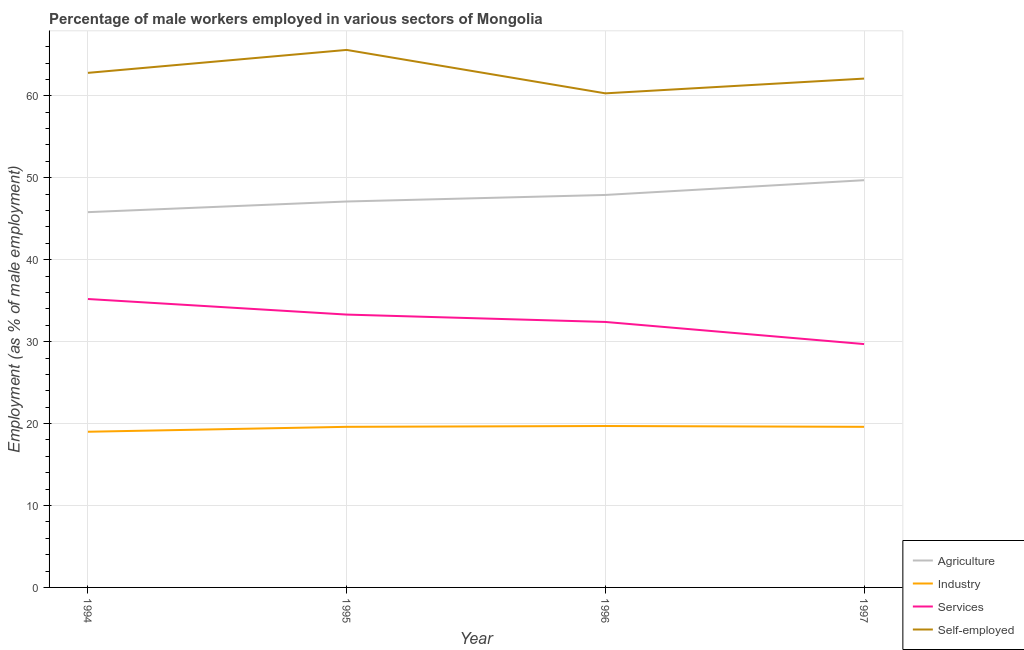How many different coloured lines are there?
Your answer should be compact. 4. Does the line corresponding to percentage of male workers in agriculture intersect with the line corresponding to percentage of self employed male workers?
Provide a short and direct response. No. Is the number of lines equal to the number of legend labels?
Your response must be concise. Yes. What is the percentage of male workers in agriculture in 1997?
Your answer should be very brief. 49.7. Across all years, what is the maximum percentage of male workers in services?
Provide a succinct answer. 35.2. Across all years, what is the minimum percentage of self employed male workers?
Your answer should be very brief. 60.3. What is the total percentage of male workers in services in the graph?
Keep it short and to the point. 130.6. What is the difference between the percentage of male workers in agriculture in 1994 and that in 1997?
Ensure brevity in your answer.  -3.9. What is the difference between the percentage of male workers in services in 1997 and the percentage of male workers in agriculture in 1995?
Offer a terse response. -17.4. What is the average percentage of self employed male workers per year?
Offer a terse response. 62.7. In the year 1997, what is the difference between the percentage of male workers in industry and percentage of male workers in agriculture?
Provide a short and direct response. -30.1. What is the ratio of the percentage of male workers in services in 1996 to that in 1997?
Your answer should be compact. 1.09. Is the percentage of self employed male workers in 1994 less than that in 1995?
Your response must be concise. Yes. Is the difference between the percentage of male workers in services in 1994 and 1997 greater than the difference between the percentage of self employed male workers in 1994 and 1997?
Provide a succinct answer. Yes. What is the difference between the highest and the second highest percentage of male workers in services?
Your answer should be very brief. 1.9. What is the difference between the highest and the lowest percentage of male workers in services?
Ensure brevity in your answer.  5.5. In how many years, is the percentage of male workers in industry greater than the average percentage of male workers in industry taken over all years?
Keep it short and to the point. 3. Is it the case that in every year, the sum of the percentage of male workers in agriculture and percentage of male workers in industry is greater than the percentage of male workers in services?
Offer a terse response. Yes. Is the percentage of male workers in industry strictly less than the percentage of self employed male workers over the years?
Your answer should be compact. Yes. What is the difference between two consecutive major ticks on the Y-axis?
Offer a terse response. 10. Does the graph contain any zero values?
Your answer should be very brief. No. Does the graph contain grids?
Provide a short and direct response. Yes. How many legend labels are there?
Keep it short and to the point. 4. What is the title of the graph?
Provide a short and direct response. Percentage of male workers employed in various sectors of Mongolia. What is the label or title of the Y-axis?
Your response must be concise. Employment (as % of male employment). What is the Employment (as % of male employment) in Agriculture in 1994?
Offer a very short reply. 45.8. What is the Employment (as % of male employment) in Services in 1994?
Your answer should be compact. 35.2. What is the Employment (as % of male employment) of Self-employed in 1994?
Your response must be concise. 62.8. What is the Employment (as % of male employment) of Agriculture in 1995?
Make the answer very short. 47.1. What is the Employment (as % of male employment) in Industry in 1995?
Provide a succinct answer. 19.6. What is the Employment (as % of male employment) of Services in 1995?
Offer a very short reply. 33.3. What is the Employment (as % of male employment) in Self-employed in 1995?
Give a very brief answer. 65.6. What is the Employment (as % of male employment) of Agriculture in 1996?
Your answer should be compact. 47.9. What is the Employment (as % of male employment) of Industry in 1996?
Ensure brevity in your answer.  19.7. What is the Employment (as % of male employment) of Services in 1996?
Keep it short and to the point. 32.4. What is the Employment (as % of male employment) of Self-employed in 1996?
Offer a terse response. 60.3. What is the Employment (as % of male employment) in Agriculture in 1997?
Keep it short and to the point. 49.7. What is the Employment (as % of male employment) of Industry in 1997?
Give a very brief answer. 19.6. What is the Employment (as % of male employment) of Services in 1997?
Your response must be concise. 29.7. What is the Employment (as % of male employment) in Self-employed in 1997?
Ensure brevity in your answer.  62.1. Across all years, what is the maximum Employment (as % of male employment) in Agriculture?
Keep it short and to the point. 49.7. Across all years, what is the maximum Employment (as % of male employment) in Industry?
Your response must be concise. 19.7. Across all years, what is the maximum Employment (as % of male employment) of Services?
Provide a succinct answer. 35.2. Across all years, what is the maximum Employment (as % of male employment) in Self-employed?
Your answer should be very brief. 65.6. Across all years, what is the minimum Employment (as % of male employment) of Agriculture?
Your response must be concise. 45.8. Across all years, what is the minimum Employment (as % of male employment) in Industry?
Ensure brevity in your answer.  19. Across all years, what is the minimum Employment (as % of male employment) in Services?
Make the answer very short. 29.7. Across all years, what is the minimum Employment (as % of male employment) in Self-employed?
Make the answer very short. 60.3. What is the total Employment (as % of male employment) in Agriculture in the graph?
Ensure brevity in your answer.  190.5. What is the total Employment (as % of male employment) of Industry in the graph?
Your answer should be very brief. 77.9. What is the total Employment (as % of male employment) in Services in the graph?
Offer a terse response. 130.6. What is the total Employment (as % of male employment) in Self-employed in the graph?
Offer a very short reply. 250.8. What is the difference between the Employment (as % of male employment) in Agriculture in 1994 and that in 1995?
Offer a very short reply. -1.3. What is the difference between the Employment (as % of male employment) in Industry in 1994 and that in 1995?
Your answer should be compact. -0.6. What is the difference between the Employment (as % of male employment) of Services in 1994 and that in 1995?
Your response must be concise. 1.9. What is the difference between the Employment (as % of male employment) in Industry in 1994 and that in 1996?
Your response must be concise. -0.7. What is the difference between the Employment (as % of male employment) in Industry in 1995 and that in 1996?
Offer a terse response. -0.1. What is the difference between the Employment (as % of male employment) in Self-employed in 1995 and that in 1997?
Your answer should be compact. 3.5. What is the difference between the Employment (as % of male employment) of Agriculture in 1996 and that in 1997?
Provide a succinct answer. -1.8. What is the difference between the Employment (as % of male employment) of Self-employed in 1996 and that in 1997?
Keep it short and to the point. -1.8. What is the difference between the Employment (as % of male employment) of Agriculture in 1994 and the Employment (as % of male employment) of Industry in 1995?
Offer a very short reply. 26.2. What is the difference between the Employment (as % of male employment) of Agriculture in 1994 and the Employment (as % of male employment) of Services in 1995?
Provide a short and direct response. 12.5. What is the difference between the Employment (as % of male employment) in Agriculture in 1994 and the Employment (as % of male employment) in Self-employed in 1995?
Ensure brevity in your answer.  -19.8. What is the difference between the Employment (as % of male employment) in Industry in 1994 and the Employment (as % of male employment) in Services in 1995?
Keep it short and to the point. -14.3. What is the difference between the Employment (as % of male employment) in Industry in 1994 and the Employment (as % of male employment) in Self-employed in 1995?
Offer a terse response. -46.6. What is the difference between the Employment (as % of male employment) of Services in 1994 and the Employment (as % of male employment) of Self-employed in 1995?
Your answer should be very brief. -30.4. What is the difference between the Employment (as % of male employment) in Agriculture in 1994 and the Employment (as % of male employment) in Industry in 1996?
Offer a terse response. 26.1. What is the difference between the Employment (as % of male employment) of Industry in 1994 and the Employment (as % of male employment) of Services in 1996?
Ensure brevity in your answer.  -13.4. What is the difference between the Employment (as % of male employment) in Industry in 1994 and the Employment (as % of male employment) in Self-employed in 1996?
Keep it short and to the point. -41.3. What is the difference between the Employment (as % of male employment) in Services in 1994 and the Employment (as % of male employment) in Self-employed in 1996?
Make the answer very short. -25.1. What is the difference between the Employment (as % of male employment) in Agriculture in 1994 and the Employment (as % of male employment) in Industry in 1997?
Offer a very short reply. 26.2. What is the difference between the Employment (as % of male employment) in Agriculture in 1994 and the Employment (as % of male employment) in Self-employed in 1997?
Offer a very short reply. -16.3. What is the difference between the Employment (as % of male employment) of Industry in 1994 and the Employment (as % of male employment) of Services in 1997?
Your response must be concise. -10.7. What is the difference between the Employment (as % of male employment) in Industry in 1994 and the Employment (as % of male employment) in Self-employed in 1997?
Provide a succinct answer. -43.1. What is the difference between the Employment (as % of male employment) of Services in 1994 and the Employment (as % of male employment) of Self-employed in 1997?
Your answer should be compact. -26.9. What is the difference between the Employment (as % of male employment) of Agriculture in 1995 and the Employment (as % of male employment) of Industry in 1996?
Your answer should be compact. 27.4. What is the difference between the Employment (as % of male employment) of Agriculture in 1995 and the Employment (as % of male employment) of Services in 1996?
Your response must be concise. 14.7. What is the difference between the Employment (as % of male employment) in Agriculture in 1995 and the Employment (as % of male employment) in Self-employed in 1996?
Your response must be concise. -13.2. What is the difference between the Employment (as % of male employment) in Industry in 1995 and the Employment (as % of male employment) in Self-employed in 1996?
Provide a succinct answer. -40.7. What is the difference between the Employment (as % of male employment) in Services in 1995 and the Employment (as % of male employment) in Self-employed in 1996?
Your answer should be very brief. -27. What is the difference between the Employment (as % of male employment) in Industry in 1995 and the Employment (as % of male employment) in Services in 1997?
Your response must be concise. -10.1. What is the difference between the Employment (as % of male employment) of Industry in 1995 and the Employment (as % of male employment) of Self-employed in 1997?
Your response must be concise. -42.5. What is the difference between the Employment (as % of male employment) in Services in 1995 and the Employment (as % of male employment) in Self-employed in 1997?
Your answer should be compact. -28.8. What is the difference between the Employment (as % of male employment) of Agriculture in 1996 and the Employment (as % of male employment) of Industry in 1997?
Your answer should be very brief. 28.3. What is the difference between the Employment (as % of male employment) of Agriculture in 1996 and the Employment (as % of male employment) of Services in 1997?
Offer a terse response. 18.2. What is the difference between the Employment (as % of male employment) of Agriculture in 1996 and the Employment (as % of male employment) of Self-employed in 1997?
Ensure brevity in your answer.  -14.2. What is the difference between the Employment (as % of male employment) in Industry in 1996 and the Employment (as % of male employment) in Services in 1997?
Provide a short and direct response. -10. What is the difference between the Employment (as % of male employment) in Industry in 1996 and the Employment (as % of male employment) in Self-employed in 1997?
Offer a terse response. -42.4. What is the difference between the Employment (as % of male employment) in Services in 1996 and the Employment (as % of male employment) in Self-employed in 1997?
Your answer should be very brief. -29.7. What is the average Employment (as % of male employment) of Agriculture per year?
Your answer should be very brief. 47.62. What is the average Employment (as % of male employment) of Industry per year?
Keep it short and to the point. 19.48. What is the average Employment (as % of male employment) of Services per year?
Give a very brief answer. 32.65. What is the average Employment (as % of male employment) of Self-employed per year?
Your response must be concise. 62.7. In the year 1994, what is the difference between the Employment (as % of male employment) of Agriculture and Employment (as % of male employment) of Industry?
Ensure brevity in your answer.  26.8. In the year 1994, what is the difference between the Employment (as % of male employment) of Agriculture and Employment (as % of male employment) of Self-employed?
Your answer should be very brief. -17. In the year 1994, what is the difference between the Employment (as % of male employment) in Industry and Employment (as % of male employment) in Services?
Keep it short and to the point. -16.2. In the year 1994, what is the difference between the Employment (as % of male employment) in Industry and Employment (as % of male employment) in Self-employed?
Ensure brevity in your answer.  -43.8. In the year 1994, what is the difference between the Employment (as % of male employment) of Services and Employment (as % of male employment) of Self-employed?
Provide a succinct answer. -27.6. In the year 1995, what is the difference between the Employment (as % of male employment) of Agriculture and Employment (as % of male employment) of Industry?
Make the answer very short. 27.5. In the year 1995, what is the difference between the Employment (as % of male employment) in Agriculture and Employment (as % of male employment) in Self-employed?
Provide a succinct answer. -18.5. In the year 1995, what is the difference between the Employment (as % of male employment) in Industry and Employment (as % of male employment) in Services?
Provide a short and direct response. -13.7. In the year 1995, what is the difference between the Employment (as % of male employment) of Industry and Employment (as % of male employment) of Self-employed?
Offer a terse response. -46. In the year 1995, what is the difference between the Employment (as % of male employment) of Services and Employment (as % of male employment) of Self-employed?
Make the answer very short. -32.3. In the year 1996, what is the difference between the Employment (as % of male employment) of Agriculture and Employment (as % of male employment) of Industry?
Your answer should be compact. 28.2. In the year 1996, what is the difference between the Employment (as % of male employment) of Agriculture and Employment (as % of male employment) of Services?
Your answer should be compact. 15.5. In the year 1996, what is the difference between the Employment (as % of male employment) of Agriculture and Employment (as % of male employment) of Self-employed?
Your response must be concise. -12.4. In the year 1996, what is the difference between the Employment (as % of male employment) of Industry and Employment (as % of male employment) of Self-employed?
Your answer should be compact. -40.6. In the year 1996, what is the difference between the Employment (as % of male employment) in Services and Employment (as % of male employment) in Self-employed?
Make the answer very short. -27.9. In the year 1997, what is the difference between the Employment (as % of male employment) of Agriculture and Employment (as % of male employment) of Industry?
Your response must be concise. 30.1. In the year 1997, what is the difference between the Employment (as % of male employment) of Agriculture and Employment (as % of male employment) of Services?
Your response must be concise. 20. In the year 1997, what is the difference between the Employment (as % of male employment) in Industry and Employment (as % of male employment) in Services?
Your response must be concise. -10.1. In the year 1997, what is the difference between the Employment (as % of male employment) of Industry and Employment (as % of male employment) of Self-employed?
Your answer should be very brief. -42.5. In the year 1997, what is the difference between the Employment (as % of male employment) in Services and Employment (as % of male employment) in Self-employed?
Your response must be concise. -32.4. What is the ratio of the Employment (as % of male employment) of Agriculture in 1994 to that in 1995?
Keep it short and to the point. 0.97. What is the ratio of the Employment (as % of male employment) of Industry in 1994 to that in 1995?
Offer a very short reply. 0.97. What is the ratio of the Employment (as % of male employment) in Services in 1994 to that in 1995?
Provide a short and direct response. 1.06. What is the ratio of the Employment (as % of male employment) in Self-employed in 1994 to that in 1995?
Your answer should be very brief. 0.96. What is the ratio of the Employment (as % of male employment) of Agriculture in 1994 to that in 1996?
Provide a short and direct response. 0.96. What is the ratio of the Employment (as % of male employment) in Industry in 1994 to that in 1996?
Offer a very short reply. 0.96. What is the ratio of the Employment (as % of male employment) of Services in 1994 to that in 1996?
Provide a succinct answer. 1.09. What is the ratio of the Employment (as % of male employment) in Self-employed in 1994 to that in 1996?
Offer a terse response. 1.04. What is the ratio of the Employment (as % of male employment) in Agriculture in 1994 to that in 1997?
Your answer should be compact. 0.92. What is the ratio of the Employment (as % of male employment) in Industry in 1994 to that in 1997?
Your response must be concise. 0.97. What is the ratio of the Employment (as % of male employment) in Services in 1994 to that in 1997?
Your answer should be very brief. 1.19. What is the ratio of the Employment (as % of male employment) in Self-employed in 1994 to that in 1997?
Ensure brevity in your answer.  1.01. What is the ratio of the Employment (as % of male employment) in Agriculture in 1995 to that in 1996?
Offer a very short reply. 0.98. What is the ratio of the Employment (as % of male employment) in Services in 1995 to that in 1996?
Offer a terse response. 1.03. What is the ratio of the Employment (as % of male employment) of Self-employed in 1995 to that in 1996?
Offer a terse response. 1.09. What is the ratio of the Employment (as % of male employment) of Agriculture in 1995 to that in 1997?
Provide a succinct answer. 0.95. What is the ratio of the Employment (as % of male employment) of Industry in 1995 to that in 1997?
Offer a terse response. 1. What is the ratio of the Employment (as % of male employment) of Services in 1995 to that in 1997?
Your response must be concise. 1.12. What is the ratio of the Employment (as % of male employment) of Self-employed in 1995 to that in 1997?
Keep it short and to the point. 1.06. What is the ratio of the Employment (as % of male employment) of Agriculture in 1996 to that in 1997?
Your response must be concise. 0.96. What is the ratio of the Employment (as % of male employment) in Services in 1996 to that in 1997?
Provide a short and direct response. 1.09. What is the ratio of the Employment (as % of male employment) in Self-employed in 1996 to that in 1997?
Make the answer very short. 0.97. What is the difference between the highest and the second highest Employment (as % of male employment) in Services?
Your answer should be compact. 1.9. What is the difference between the highest and the second highest Employment (as % of male employment) in Self-employed?
Your answer should be compact. 2.8. What is the difference between the highest and the lowest Employment (as % of male employment) in Industry?
Keep it short and to the point. 0.7. What is the difference between the highest and the lowest Employment (as % of male employment) in Services?
Provide a short and direct response. 5.5. What is the difference between the highest and the lowest Employment (as % of male employment) in Self-employed?
Give a very brief answer. 5.3. 